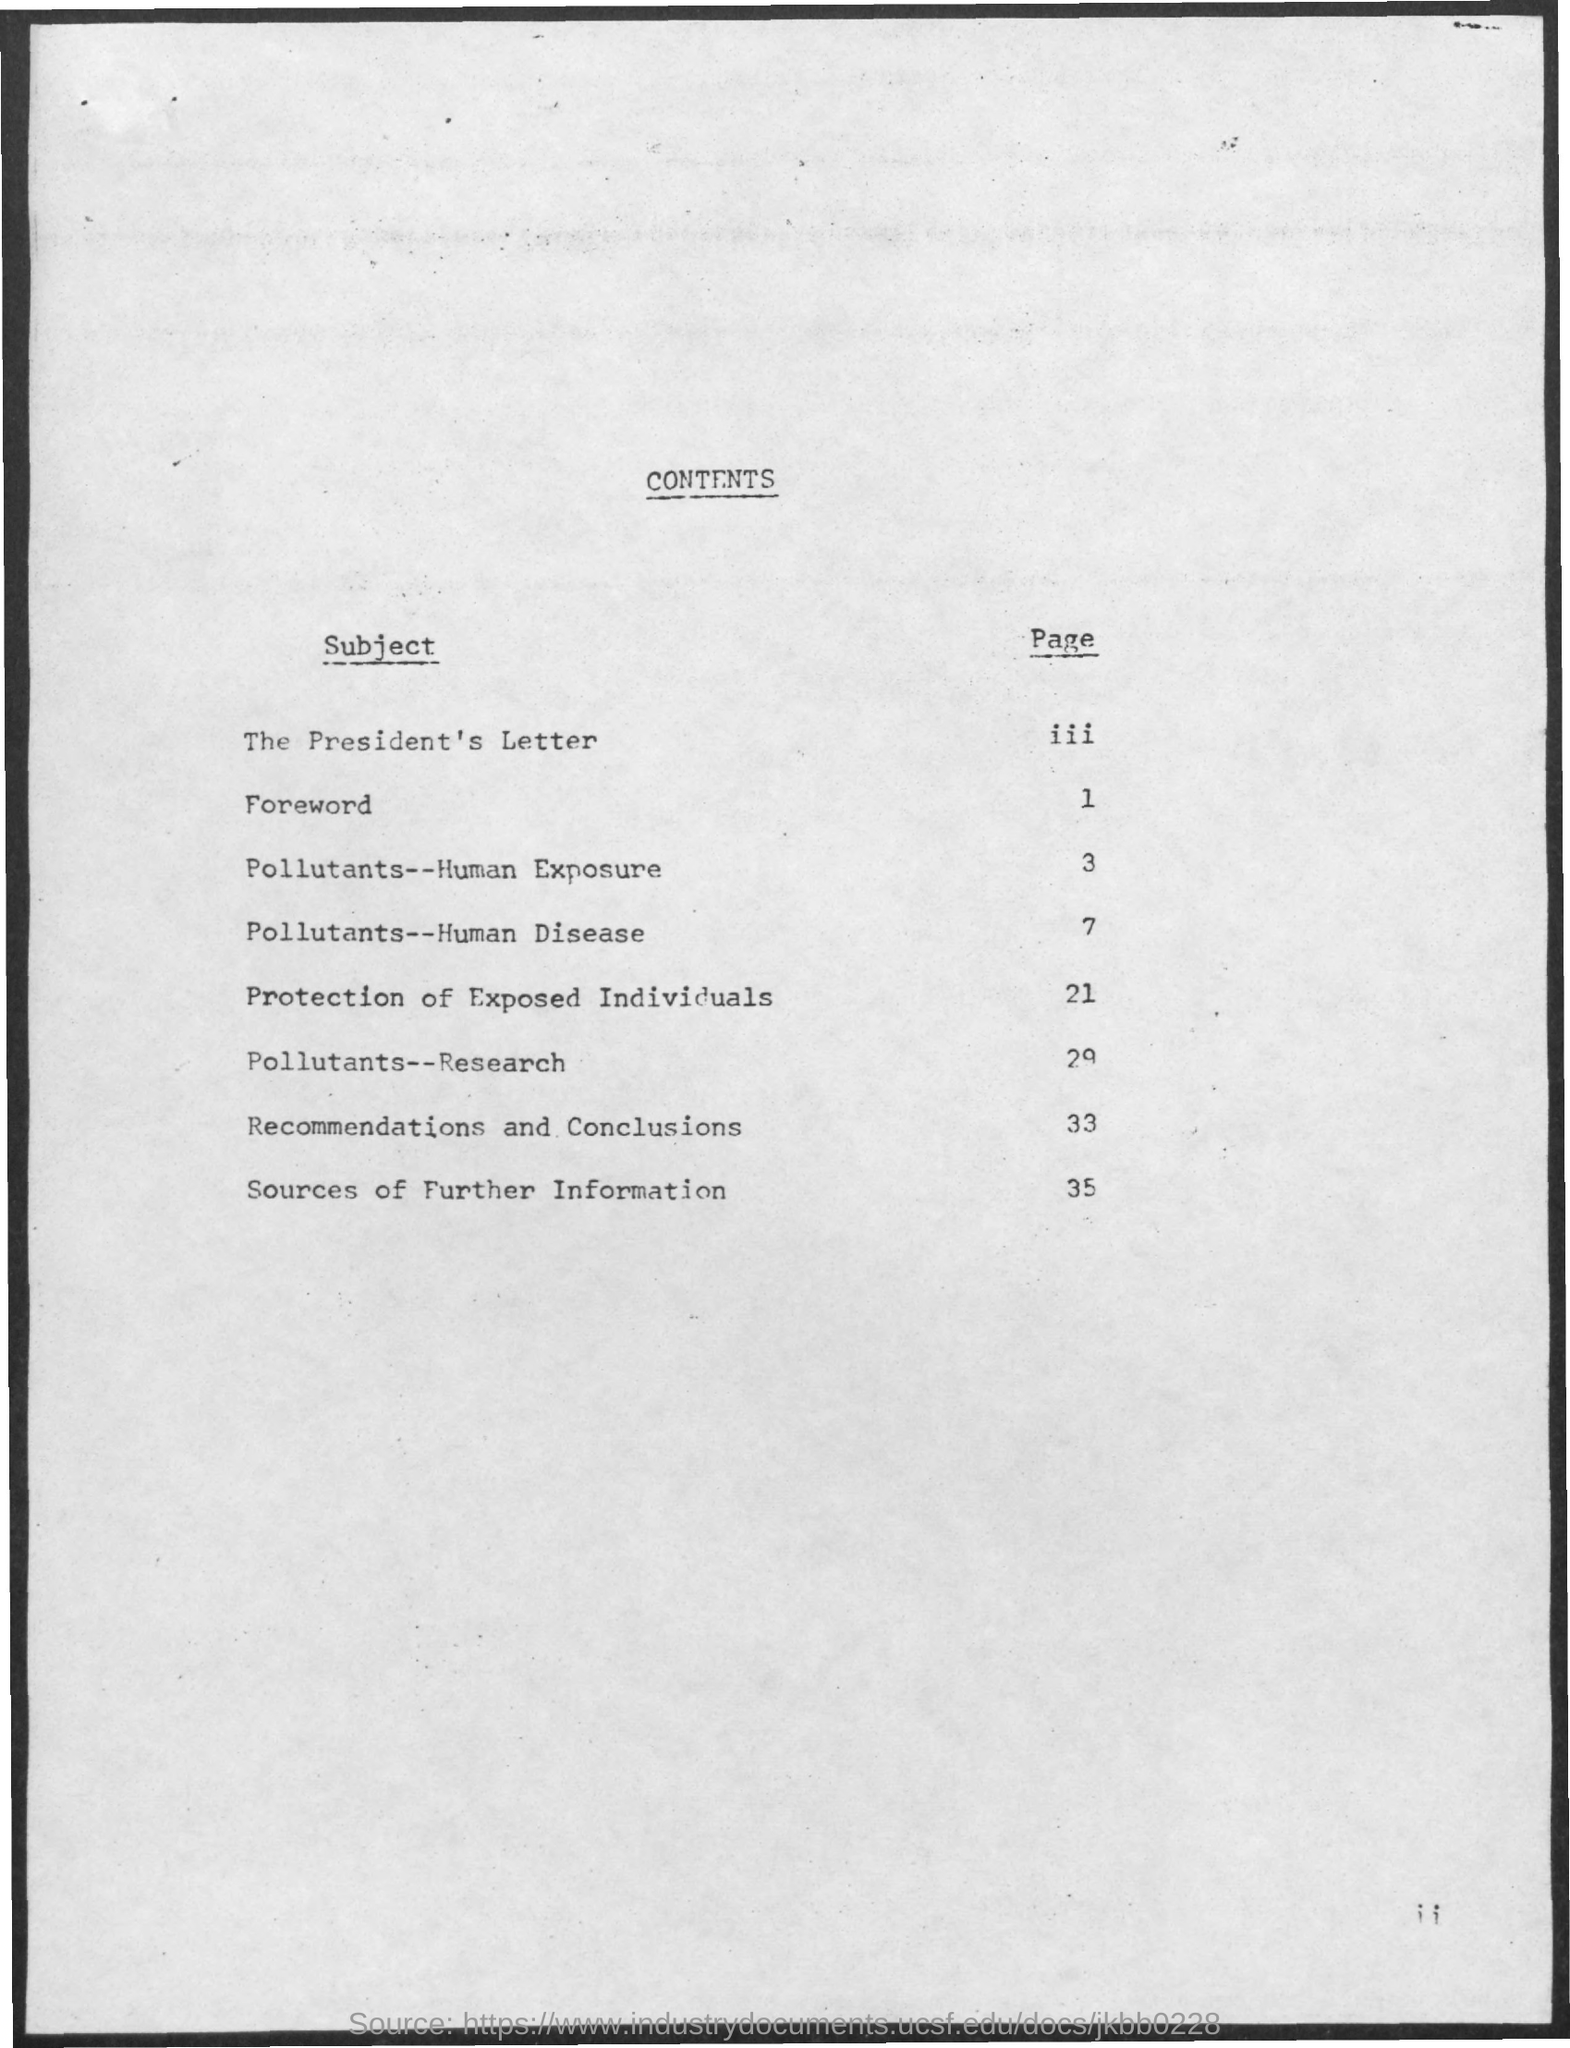what is the page no. for protection of exposed individuals subject ?
 21 